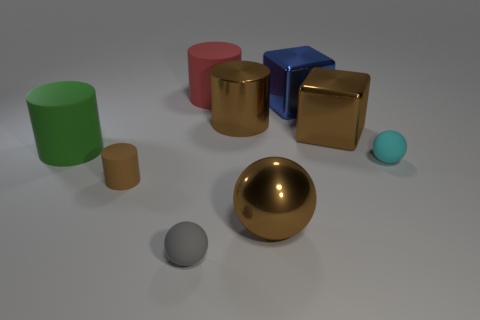Add 1 small gray matte spheres. How many objects exist? 10 Subtract all cylinders. How many objects are left? 5 Add 1 cyan rubber objects. How many cyan rubber objects are left? 2 Add 2 tiny objects. How many tiny objects exist? 5 Subtract 0 green cubes. How many objects are left? 9 Subtract all cyan balls. Subtract all big red spheres. How many objects are left? 8 